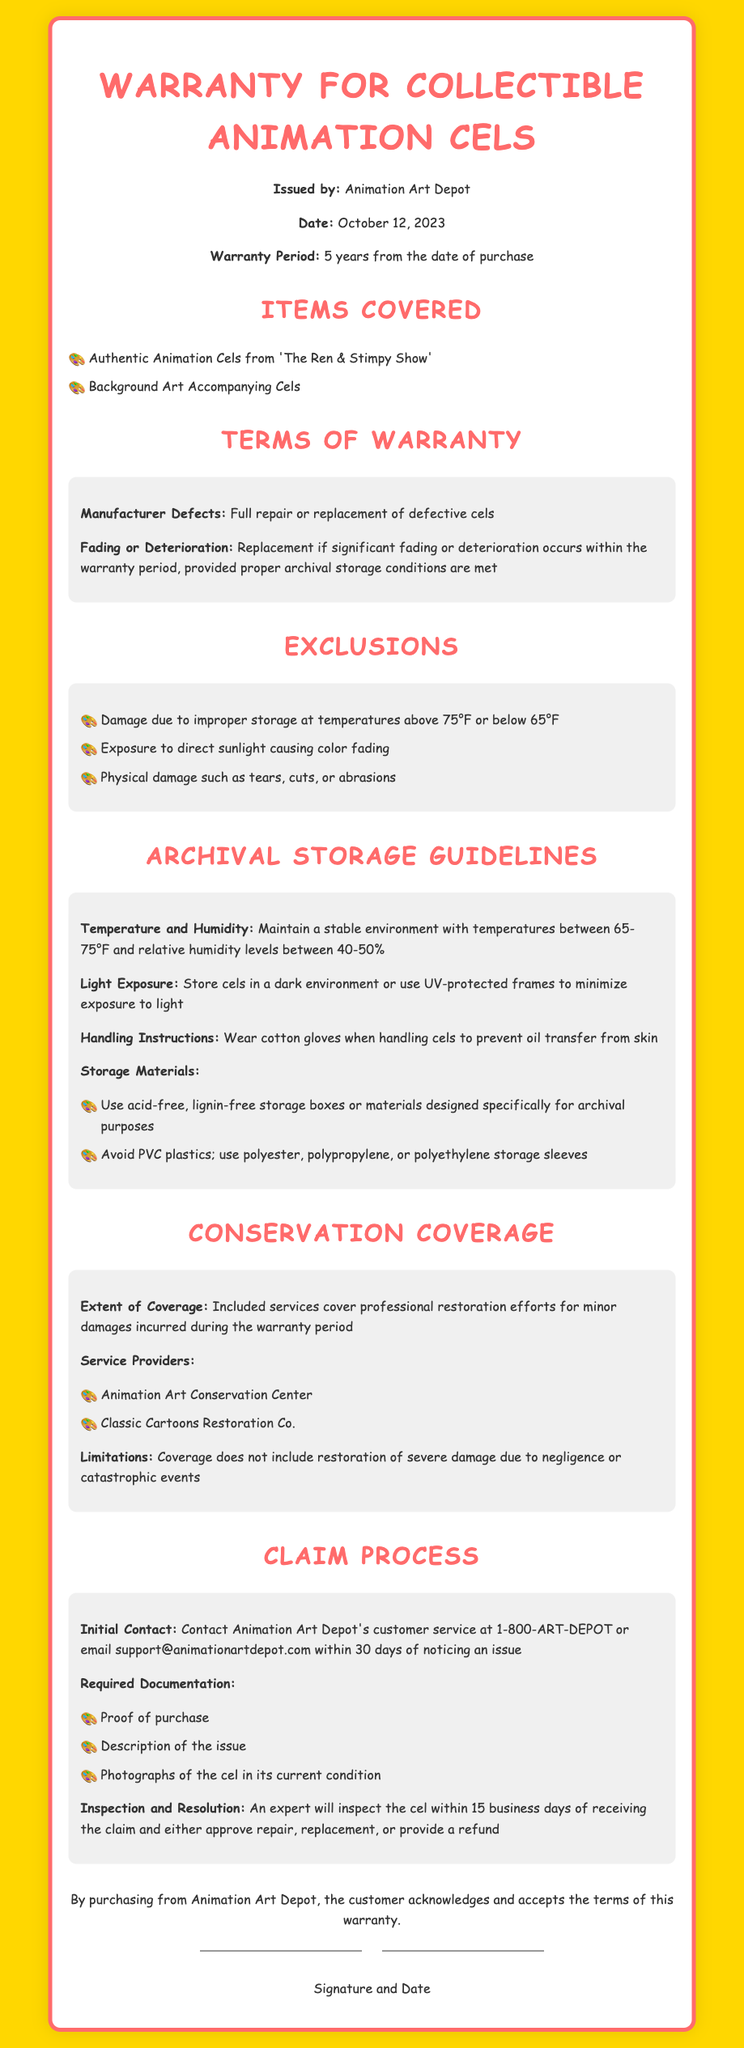What is the issuing organization? The document states that the warranty is issued by Animation Art Depot.
Answer: Animation Art Depot What is the warranty period? The warranty period is specified as 5 years from the date of purchase.
Answer: 5 years What items are covered under this warranty? The covered items are listed as authentic animation cels from 'The Ren & Stimpy Show' and background art accompanying cels.
Answer: Authentic Animation Cels from 'The Ren & Stimpy Show', Background Art What is excluded from the warranty coverage? One of the exclusions mentioned is damage due to improper storage at temperatures above 75°F or below 65°F.
Answer: Improper storage What temperature range should be maintained for archival storage? The document advises maintaining temperatures between 65-75°F for archival storage conditions.
Answer: 65-75°F Who should be contacted for claims? The warranty document specifies that claims should be directed to Animation Art Depot's customer service.
Answer: Animation Art Depot What is required for the initial claim submission? Required documentation includes proof of purchase, a description of the issue, and photographs of the cel.
Answer: Proof of purchase, description of the issue, photographs What is the timeframe for inspection after a claim is submitted? An expert will inspect the cel within 15 business days of receiving the claim.
Answer: 15 business days What type of gloves should be worn when handling the cels? The guidelines recommend wearing cotton gloves to prevent oil transfer from skin.
Answer: Cotton gloves What type of materials should be avoided for storage? The document specifies avoiding PVC plastics for storage.
Answer: PVC plastics 